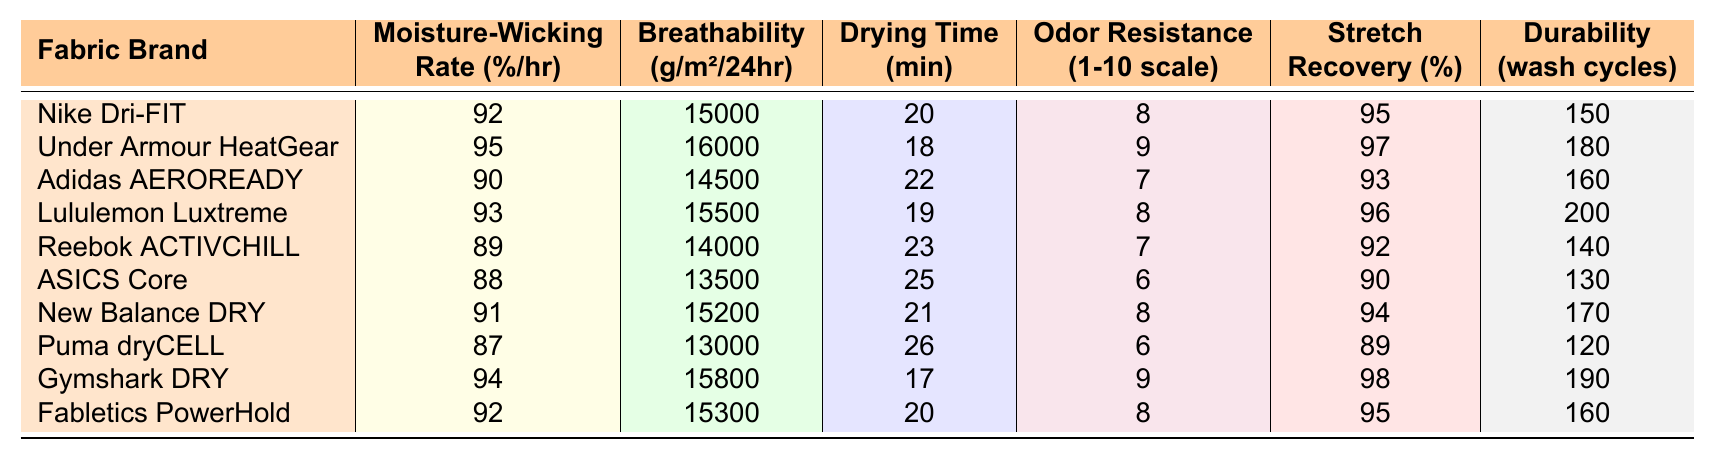What is the moisture-wicking rate of Under Armour HeatGear? The table indicates that the moisture-wicking rate for Under Armour HeatGear is 95% per hour.
Answer: 95% Which fabric has the fastest drying time? By scanning the drying times, Puma dryCELL has the fastest drying time listed at 26 minutes.
Answer: 26 minutes What is the odor resistance rating for Nike Dri-FIT? The odor resistance rating for Nike Dri-FIT is 8 on a scale of 1 to 10, as displayed in the table.
Answer: 8 What is the average moisture-wicking rate of the fabrics listed? The sum of the moisture-wicking rates is 92 + 95 + 90 + 93 + 89 + 88 + 91 + 87 + 94 + 92 = 910. With 10 samples, the average is 910/10 = 91.
Answer: 91% Which fabric has the highest breathability? Looking at the breathability values, Under Armour HeatGear has the highest breathability at 16000 g/m²/24hr.
Answer: 16000 g/m²/24hr Is the stretch recovery of Lululemon Luxtreme greater than 95%? The stretch recovery for Lululemon Luxtreme is 96%, which is indeed greater than 95%.
Answer: Yes How does the durability of Reebok ACTIVCHILL compare to ASICS Core? Reebok ACTIVCHILL has a durability of 140 wash cycles, while ASICS Core only has 130 wash cycles. Therefore, Reebok ACTIVCHILL is more durable.
Answer: Reebok ACTIVCHILL is more durable What is the difference in moisture-wicking rate between Gymshark DRY and ASICS Core? Gymshark DRY has a moisture-wicking rate of 94% while ASICS Core has 88%. The difference is 94 - 88 = 6%.
Answer: 6% What fabric has the lowest odor resistance rating? The table shows that ASICS Core has the lowest odor resistance rating at 6.
Answer: 6 Which two fabrics have a moisture-wicking rate above 92% and also have a stretch recovery rate above 95%? Examining the data, Under Armour HeatGear (95%, 97%) and Gymshark DRY (94%, 98%) meet both criteria.
Answer: Under Armour HeatGear and Gymshark DRY 